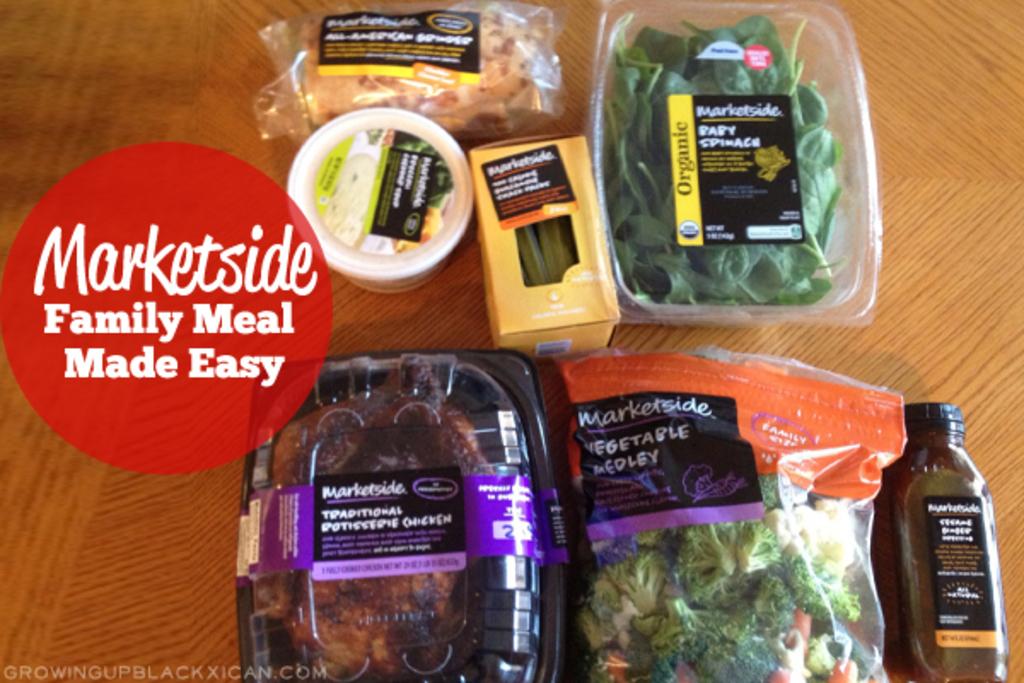What brand do these food products belong to?
Your answer should be very brief. Marketside. 